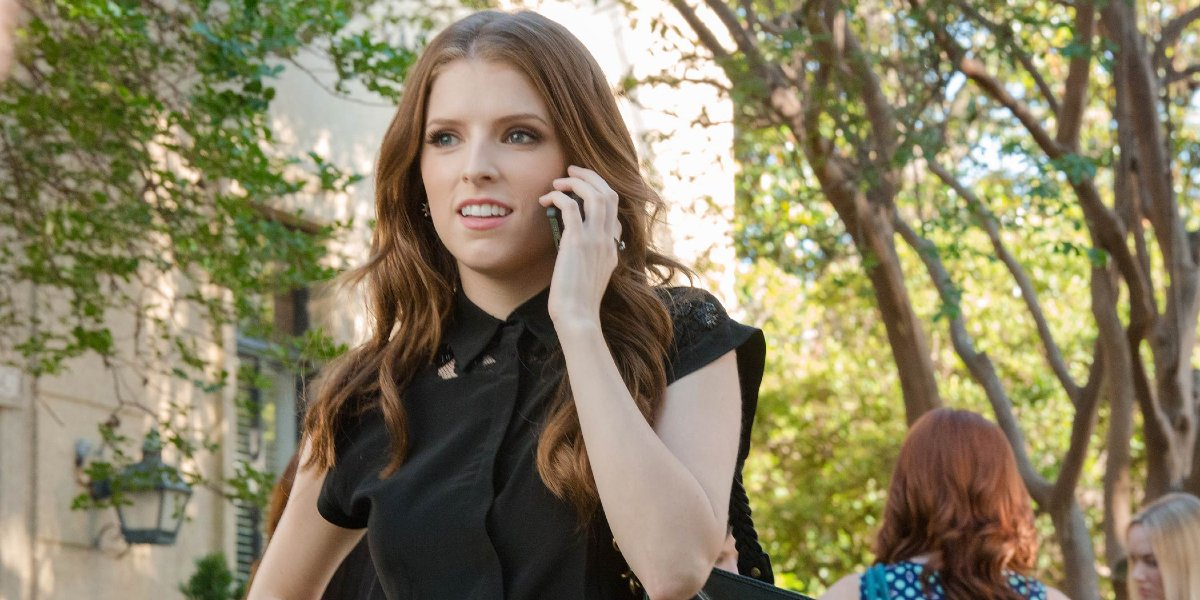If you could hear her conversation, what realistic scenario might she be discussing? Realistically, she might be discussing a dilemma she’s facing at work, perhaps a decision that could impact her team or a project. Alternatively, she could be talking about a personal matter, such as a conflict with a close friend or family member. The concern on her face suggests the topic is significant and weighs heavily on her mind, requiring delicate handling and thoughtful advice. What if her conversation was about a lighter topic? If her conversation was about a lighter topic, she might be chatting with a friend making plans for the weekend or discussing details of an upcoming event she's looking forward to. Despite the slight concern in her expression, she could be offering advice on something trivial or simply catching up on recent happenings with someone close to her. 